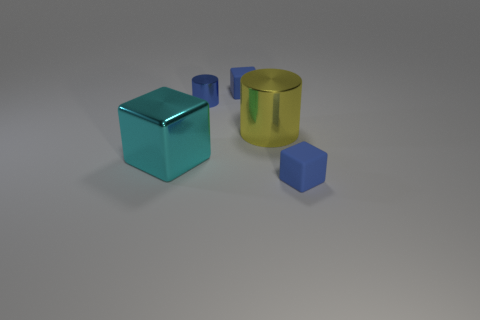Subtract all tiny matte blocks. How many blocks are left? 1 Subtract all blue balls. How many blue blocks are left? 2 Add 2 tiny blue matte cylinders. How many objects exist? 7 Subtract all cubes. How many objects are left? 2 Subtract all purple blocks. Subtract all red balls. How many blocks are left? 3 Add 5 blue cylinders. How many blue cylinders exist? 6 Subtract 0 red blocks. How many objects are left? 5 Subtract all large shiny cylinders. Subtract all tiny blue cylinders. How many objects are left? 3 Add 3 metallic things. How many metallic things are left? 6 